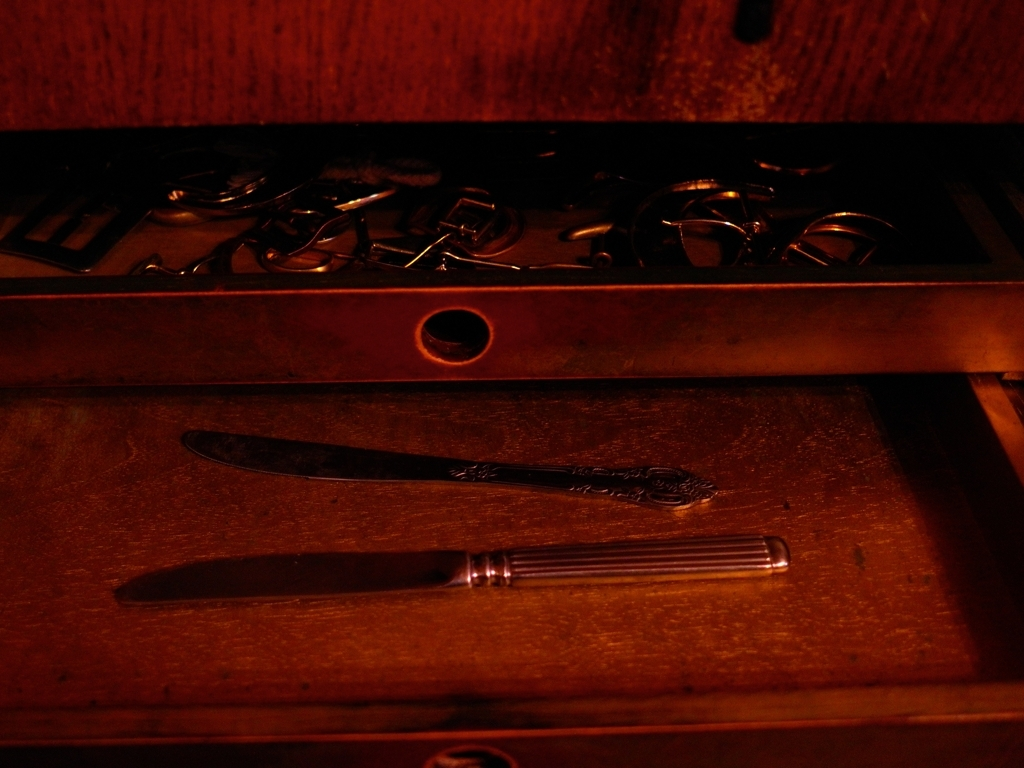What items can be seen in the drawer, and what might their condition suggest about their usage? The drawer contains several items, including loose keys, a pair of scissors, and two flatware pieces - a knife and a spoon. The arrangement is somewhat disorganized, implying these items might be infrequently used or stored haphazardly. Their condition, with visible wear, also suggests they may be old or antique. 